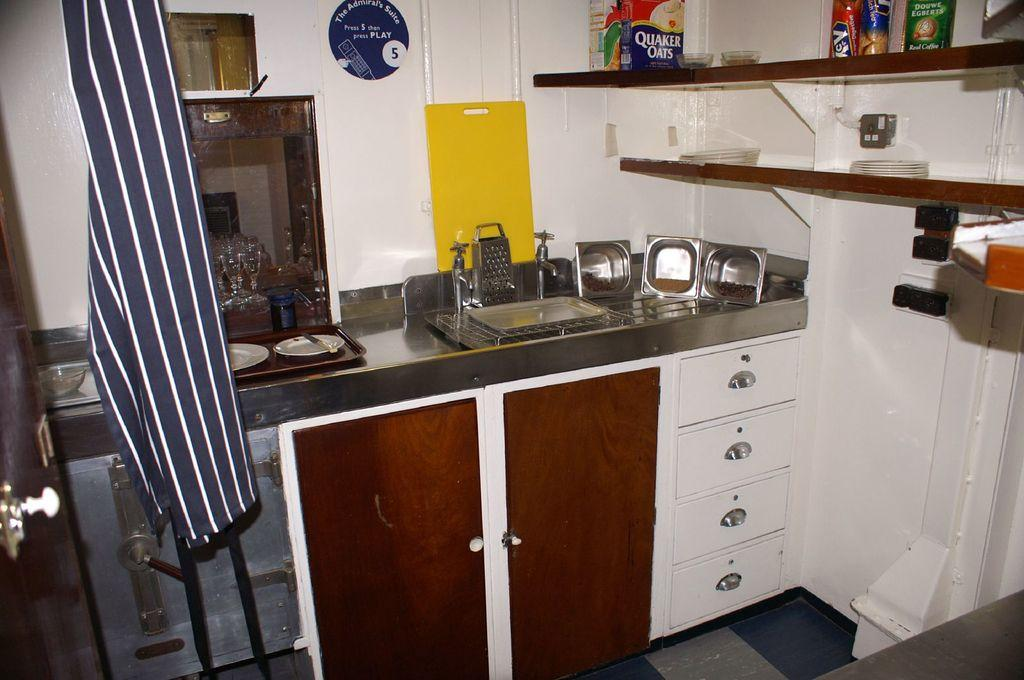<image>
Create a compact narrative representing the image presented. A box of Quaker Oats sits on the top shelf above the sink. 